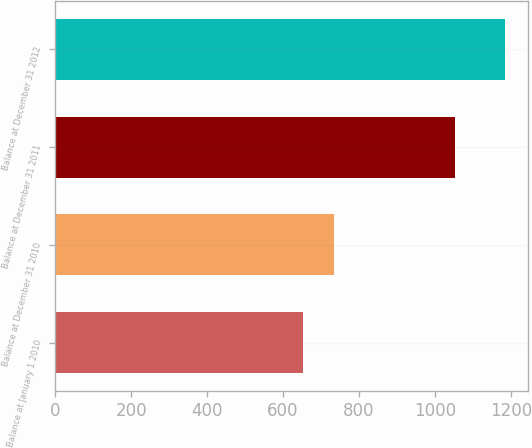Convert chart. <chart><loc_0><loc_0><loc_500><loc_500><bar_chart><fcel>Balance at January 1 2010<fcel>Balance at December 31 2010<fcel>Balance at December 31 2011<fcel>Balance at December 31 2012<nl><fcel>654<fcel>734<fcel>1054<fcel>1186<nl></chart> 